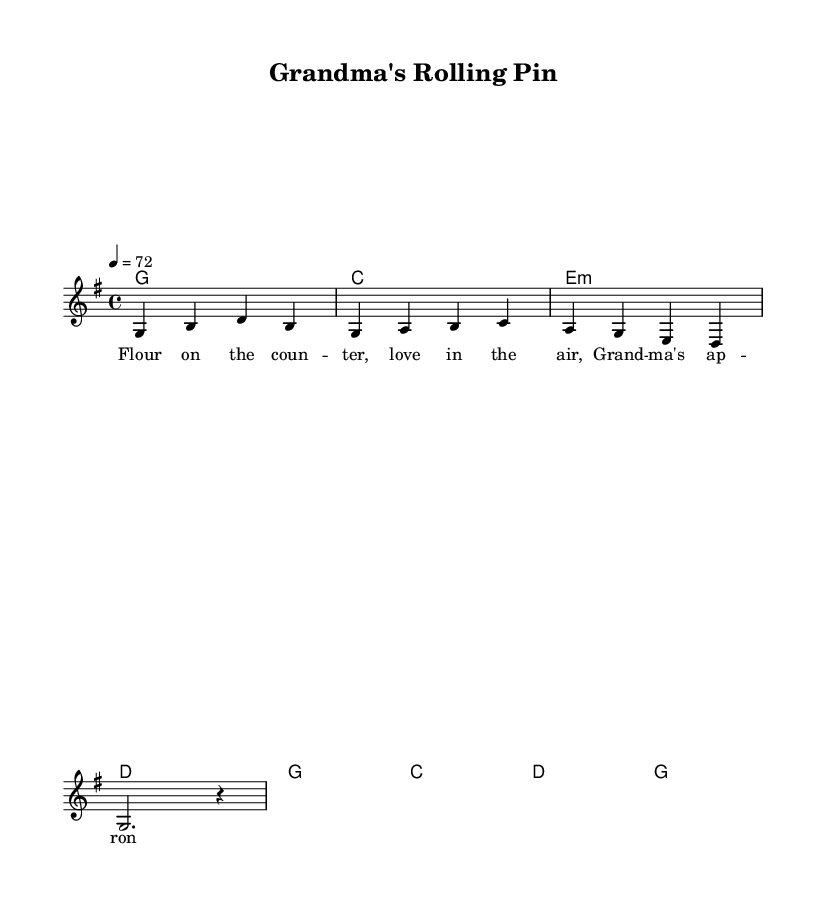What is the key signature of this music? The key signature is G major, which has one sharp (F#). This can be determined by identifying the sharp symbol indicated at the beginning of the staff just after the clef symbol.
Answer: G major What is the time signature of this music? The time signature is 4/4, meaning there are four beats in each measure and the quarter note gets one beat. This is noted at the beginning of the staff, next to the key signature.
Answer: 4/4 What is the tempo marking in this music? The tempo marking is 72 beats per minute, indicated in the score with the notation "4 = 72" stating that a quarter note gets 72 beats.
Answer: 72 How many measures are in the melody? The melody consists of eight measures, which can be counted by looking at the lines separating each set of notes in the music. Each musical line and its contents represent one measure.
Answer: Eight What is the first note of the melody? The first note of the melody is G, which is indicated at the beginning of the melody line in the score.
Answer: G What type of voicing is used in this music? The music features a lead voice with chordal harmony underneath, as shown by the separate staff for the melody and the chord names at the top of the score. This is typical for country rock where the melody is emphasized over harmonic support.
Answer: Lead voice with harmony What theme does the lyrics of this piece represent? The lyrics celebrate a family-owned bakery, which is evident from phrases referencing flour and Grandma's apron, indicating a warm, nostalgic connection. This theme is common in country rock, reflecting personal and familial stories.
Answer: Family-owned bakery 